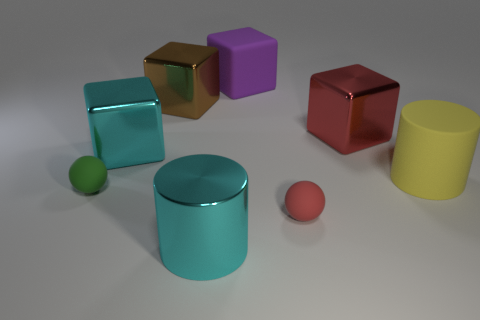What number of big cyan objects are the same shape as the brown metal object?
Provide a short and direct response. 1. There is a tiny sphere that is on the right side of the green rubber ball; is its color the same as the shiny block in front of the big red shiny thing?
Offer a very short reply. No. There is a yellow object that is the same size as the purple thing; what is its material?
Offer a very short reply. Rubber. Are there any cubes that have the same size as the matte cylinder?
Make the answer very short. Yes. Are there fewer purple things that are left of the big brown metal block than small gray rubber blocks?
Ensure brevity in your answer.  No. Are there fewer cylinders that are left of the tiny green matte thing than tiny red things that are in front of the metallic cylinder?
Ensure brevity in your answer.  No. How many cubes are large rubber objects or metallic things?
Your response must be concise. 4. Is the material of the cyan thing that is in front of the matte cylinder the same as the large red object that is behind the tiny green matte object?
Ensure brevity in your answer.  Yes. What is the shape of the red thing that is the same size as the purple block?
Offer a terse response. Cube. What number of other objects are there of the same color as the large rubber cylinder?
Your answer should be compact. 0. 